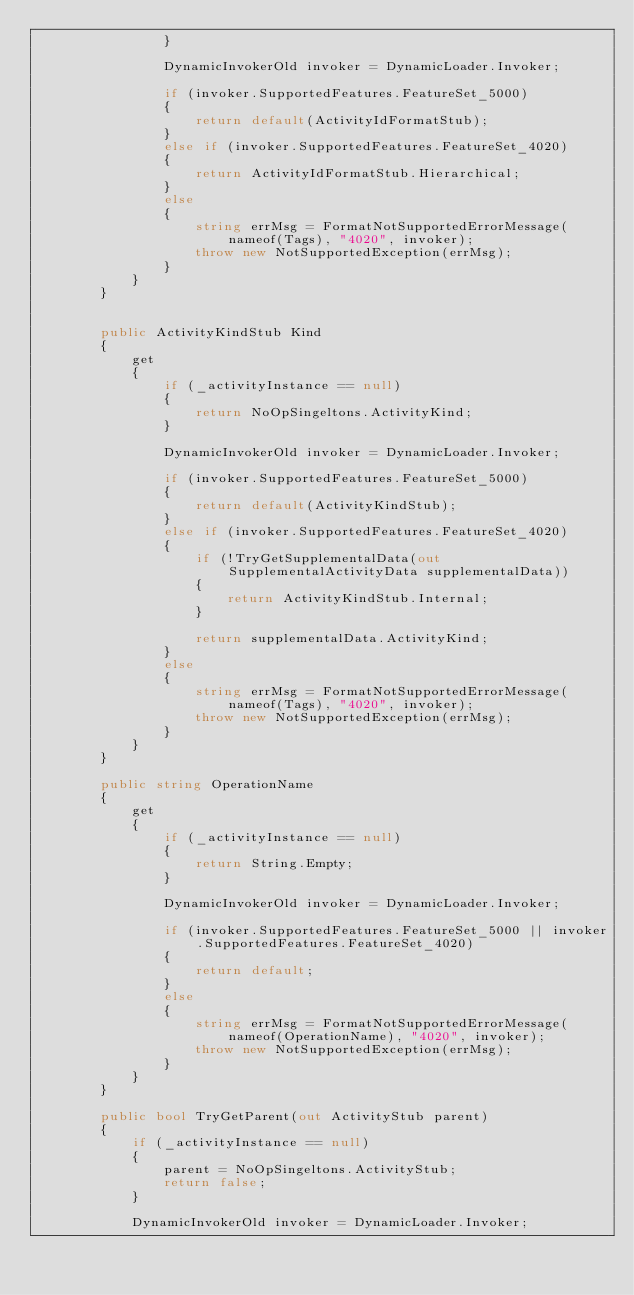Convert code to text. <code><loc_0><loc_0><loc_500><loc_500><_C#_>                }

                DynamicInvokerOld invoker = DynamicLoader.Invoker;

                if (invoker.SupportedFeatures.FeatureSet_5000)
                {
                    return default(ActivityIdFormatStub);
                }
                else if (invoker.SupportedFeatures.FeatureSet_4020)
                {
                    return ActivityIdFormatStub.Hierarchical;
                }
                else
                {
                    string errMsg = FormatNotSupportedErrorMessage(nameof(Tags), "4020", invoker);
                    throw new NotSupportedException(errMsg);
                }
            }
        }


        public ActivityKindStub Kind
        {
            get
            {
                if (_activityInstance == null)
                {
                    return NoOpSingeltons.ActivityKind;
                }

                DynamicInvokerOld invoker = DynamicLoader.Invoker;

                if (invoker.SupportedFeatures.FeatureSet_5000)
                {
                    return default(ActivityKindStub);
                }
                else if (invoker.SupportedFeatures.FeatureSet_4020)
                {
                    if (!TryGetSupplementalData(out SupplementalActivityData supplementalData))
                    {
                        return ActivityKindStub.Internal;
                    }

                    return supplementalData.ActivityKind;
                }
                else
                {
                    string errMsg = FormatNotSupportedErrorMessage(nameof(Tags), "4020", invoker);
                    throw new NotSupportedException(errMsg);
                }
            }
        }

        public string OperationName
        {
            get
            {
                if (_activityInstance == null)
                {
                    return String.Empty;
                }

                DynamicInvokerOld invoker = DynamicLoader.Invoker;

                if (invoker.SupportedFeatures.FeatureSet_5000 || invoker.SupportedFeatures.FeatureSet_4020)
                {
                    return default;
                }
                else
                {
                    string errMsg = FormatNotSupportedErrorMessage(nameof(OperationName), "4020", invoker);
                    throw new NotSupportedException(errMsg);
                }
            }
        }

        public bool TryGetParent(out ActivityStub parent)
        {
            if (_activityInstance == null)
            {
                parent = NoOpSingeltons.ActivityStub;
                return false;
            }

            DynamicInvokerOld invoker = DynamicLoader.Invoker;
</code> 